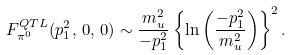Convert formula to latex. <formula><loc_0><loc_0><loc_500><loc_500>F _ { \pi ^ { 0 } } ^ { Q T L } ( p _ { 1 } ^ { 2 } , \, 0 , \, 0 ) \sim { \frac { m _ { u } ^ { 2 } } { - p _ { 1 } ^ { 2 } } } \left \{ \ln \left ( \frac { - p _ { 1 } ^ { 2 } } { m _ { u } ^ { 2 } } \right ) \right \} ^ { 2 } .</formula> 